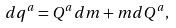Convert formula to latex. <formula><loc_0><loc_0><loc_500><loc_500>d q ^ { a } = Q ^ { a } d m + m d Q ^ { a } ,</formula> 